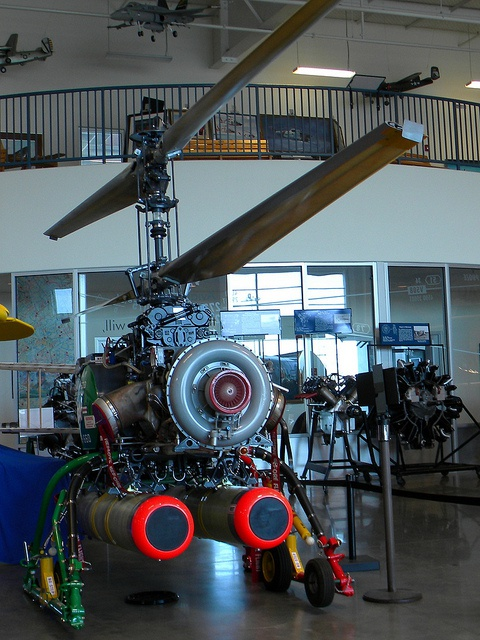Describe the objects in this image and their specific colors. I can see airplane in gray, black, maroon, and navy tones and airplane in gray and black tones in this image. 